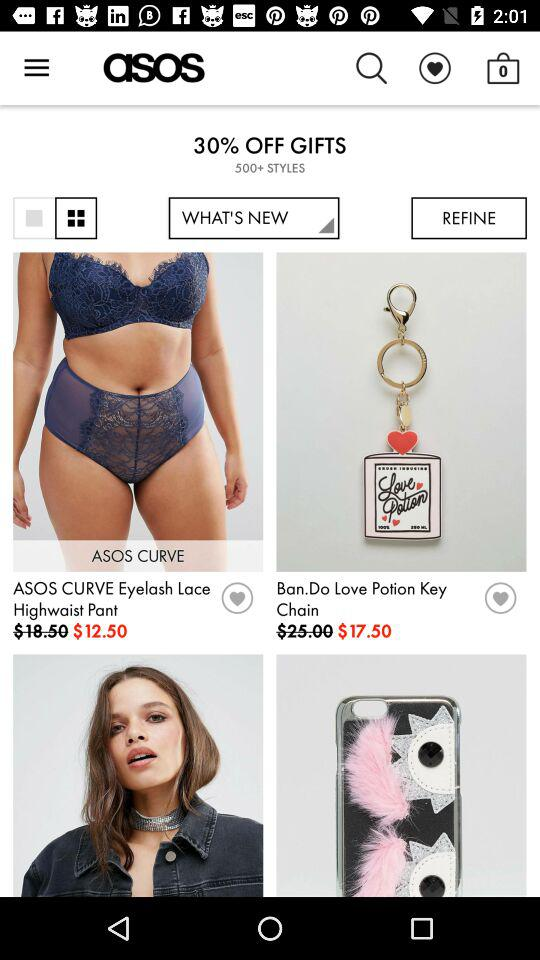How many items have a price of less than $20?
Answer the question using a single word or phrase. 2 